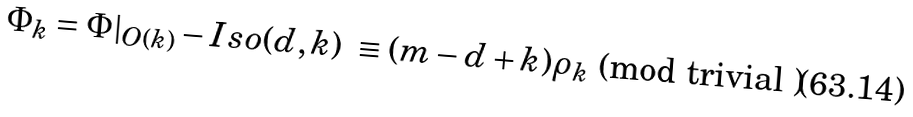<formula> <loc_0><loc_0><loc_500><loc_500>\Phi _ { k } = \Phi | _ { O ( k ) } - I s o ( d , k ) \ \equiv ( m - d + k ) \rho _ { k } \text { (mod trivial )} \</formula> 